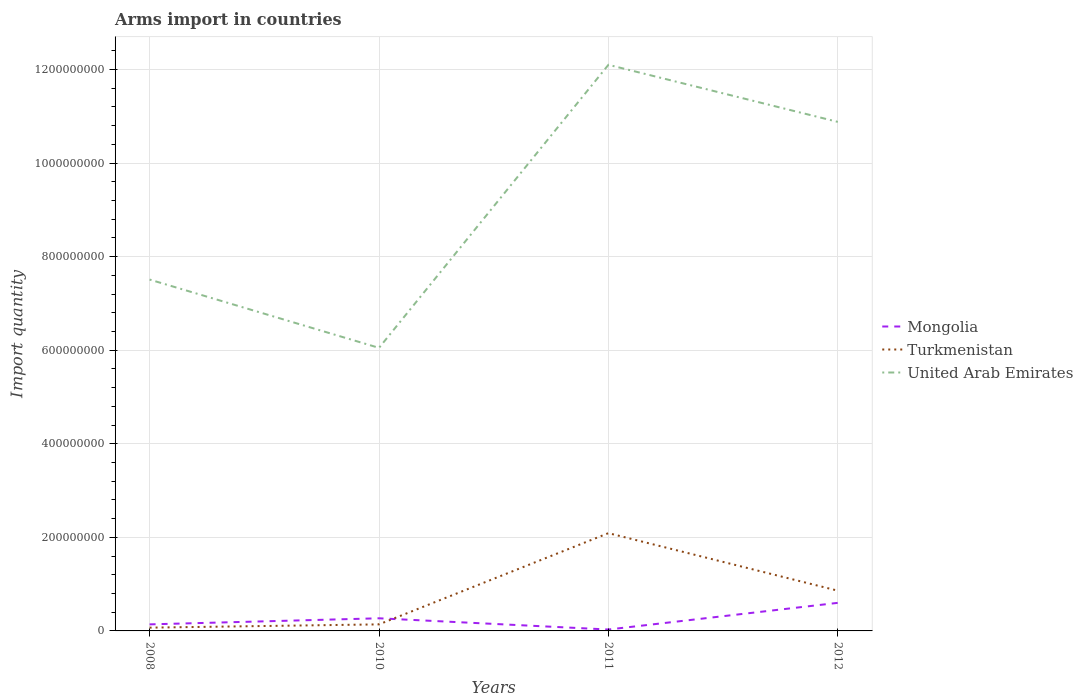How many different coloured lines are there?
Your answer should be compact. 3. Does the line corresponding to Turkmenistan intersect with the line corresponding to United Arab Emirates?
Your answer should be very brief. No. In which year was the total arms import in Turkmenistan maximum?
Make the answer very short. 2008. What is the total total arms import in Mongolia in the graph?
Provide a short and direct response. -3.30e+07. What is the difference between the highest and the second highest total arms import in United Arab Emirates?
Your response must be concise. 6.05e+08. What is the difference between the highest and the lowest total arms import in Mongolia?
Make the answer very short. 2. How many years are there in the graph?
Keep it short and to the point. 4. Are the values on the major ticks of Y-axis written in scientific E-notation?
Make the answer very short. No. Does the graph contain grids?
Your answer should be compact. Yes. How are the legend labels stacked?
Ensure brevity in your answer.  Vertical. What is the title of the graph?
Your answer should be very brief. Arms import in countries. What is the label or title of the X-axis?
Keep it short and to the point. Years. What is the label or title of the Y-axis?
Provide a short and direct response. Import quantity. What is the Import quantity of Mongolia in 2008?
Your answer should be very brief. 1.40e+07. What is the Import quantity in Turkmenistan in 2008?
Ensure brevity in your answer.  7.00e+06. What is the Import quantity of United Arab Emirates in 2008?
Your response must be concise. 7.51e+08. What is the Import quantity in Mongolia in 2010?
Make the answer very short. 2.70e+07. What is the Import quantity in Turkmenistan in 2010?
Make the answer very short. 1.40e+07. What is the Import quantity in United Arab Emirates in 2010?
Ensure brevity in your answer.  6.05e+08. What is the Import quantity of Turkmenistan in 2011?
Your response must be concise. 2.09e+08. What is the Import quantity of United Arab Emirates in 2011?
Your answer should be compact. 1.21e+09. What is the Import quantity in Mongolia in 2012?
Your answer should be compact. 6.00e+07. What is the Import quantity of Turkmenistan in 2012?
Offer a terse response. 8.60e+07. What is the Import quantity in United Arab Emirates in 2012?
Offer a very short reply. 1.09e+09. Across all years, what is the maximum Import quantity in Mongolia?
Ensure brevity in your answer.  6.00e+07. Across all years, what is the maximum Import quantity of Turkmenistan?
Provide a short and direct response. 2.09e+08. Across all years, what is the maximum Import quantity of United Arab Emirates?
Make the answer very short. 1.21e+09. Across all years, what is the minimum Import quantity of Turkmenistan?
Give a very brief answer. 7.00e+06. Across all years, what is the minimum Import quantity of United Arab Emirates?
Give a very brief answer. 6.05e+08. What is the total Import quantity in Mongolia in the graph?
Make the answer very short. 1.04e+08. What is the total Import quantity of Turkmenistan in the graph?
Offer a terse response. 3.16e+08. What is the total Import quantity of United Arab Emirates in the graph?
Provide a succinct answer. 3.65e+09. What is the difference between the Import quantity of Mongolia in 2008 and that in 2010?
Your answer should be very brief. -1.30e+07. What is the difference between the Import quantity of Turkmenistan in 2008 and that in 2010?
Your response must be concise. -7.00e+06. What is the difference between the Import quantity in United Arab Emirates in 2008 and that in 2010?
Keep it short and to the point. 1.46e+08. What is the difference between the Import quantity in Mongolia in 2008 and that in 2011?
Your answer should be compact. 1.10e+07. What is the difference between the Import quantity in Turkmenistan in 2008 and that in 2011?
Your response must be concise. -2.02e+08. What is the difference between the Import quantity in United Arab Emirates in 2008 and that in 2011?
Give a very brief answer. -4.59e+08. What is the difference between the Import quantity in Mongolia in 2008 and that in 2012?
Provide a short and direct response. -4.60e+07. What is the difference between the Import quantity of Turkmenistan in 2008 and that in 2012?
Provide a short and direct response. -7.90e+07. What is the difference between the Import quantity of United Arab Emirates in 2008 and that in 2012?
Provide a short and direct response. -3.37e+08. What is the difference between the Import quantity of Mongolia in 2010 and that in 2011?
Ensure brevity in your answer.  2.40e+07. What is the difference between the Import quantity of Turkmenistan in 2010 and that in 2011?
Provide a short and direct response. -1.95e+08. What is the difference between the Import quantity in United Arab Emirates in 2010 and that in 2011?
Offer a terse response. -6.05e+08. What is the difference between the Import quantity in Mongolia in 2010 and that in 2012?
Keep it short and to the point. -3.30e+07. What is the difference between the Import quantity of Turkmenistan in 2010 and that in 2012?
Keep it short and to the point. -7.20e+07. What is the difference between the Import quantity in United Arab Emirates in 2010 and that in 2012?
Keep it short and to the point. -4.83e+08. What is the difference between the Import quantity in Mongolia in 2011 and that in 2012?
Your answer should be very brief. -5.70e+07. What is the difference between the Import quantity in Turkmenistan in 2011 and that in 2012?
Provide a short and direct response. 1.23e+08. What is the difference between the Import quantity in United Arab Emirates in 2011 and that in 2012?
Offer a very short reply. 1.22e+08. What is the difference between the Import quantity of Mongolia in 2008 and the Import quantity of Turkmenistan in 2010?
Provide a succinct answer. 0. What is the difference between the Import quantity of Mongolia in 2008 and the Import quantity of United Arab Emirates in 2010?
Give a very brief answer. -5.91e+08. What is the difference between the Import quantity of Turkmenistan in 2008 and the Import quantity of United Arab Emirates in 2010?
Provide a short and direct response. -5.98e+08. What is the difference between the Import quantity of Mongolia in 2008 and the Import quantity of Turkmenistan in 2011?
Your answer should be compact. -1.95e+08. What is the difference between the Import quantity in Mongolia in 2008 and the Import quantity in United Arab Emirates in 2011?
Give a very brief answer. -1.20e+09. What is the difference between the Import quantity in Turkmenistan in 2008 and the Import quantity in United Arab Emirates in 2011?
Offer a very short reply. -1.20e+09. What is the difference between the Import quantity of Mongolia in 2008 and the Import quantity of Turkmenistan in 2012?
Ensure brevity in your answer.  -7.20e+07. What is the difference between the Import quantity of Mongolia in 2008 and the Import quantity of United Arab Emirates in 2012?
Offer a terse response. -1.07e+09. What is the difference between the Import quantity of Turkmenistan in 2008 and the Import quantity of United Arab Emirates in 2012?
Provide a short and direct response. -1.08e+09. What is the difference between the Import quantity of Mongolia in 2010 and the Import quantity of Turkmenistan in 2011?
Provide a succinct answer. -1.82e+08. What is the difference between the Import quantity in Mongolia in 2010 and the Import quantity in United Arab Emirates in 2011?
Make the answer very short. -1.18e+09. What is the difference between the Import quantity in Turkmenistan in 2010 and the Import quantity in United Arab Emirates in 2011?
Your response must be concise. -1.20e+09. What is the difference between the Import quantity of Mongolia in 2010 and the Import quantity of Turkmenistan in 2012?
Your answer should be compact. -5.90e+07. What is the difference between the Import quantity of Mongolia in 2010 and the Import quantity of United Arab Emirates in 2012?
Offer a terse response. -1.06e+09. What is the difference between the Import quantity of Turkmenistan in 2010 and the Import quantity of United Arab Emirates in 2012?
Offer a very short reply. -1.07e+09. What is the difference between the Import quantity in Mongolia in 2011 and the Import quantity in Turkmenistan in 2012?
Provide a short and direct response. -8.30e+07. What is the difference between the Import quantity of Mongolia in 2011 and the Import quantity of United Arab Emirates in 2012?
Provide a short and direct response. -1.08e+09. What is the difference between the Import quantity of Turkmenistan in 2011 and the Import quantity of United Arab Emirates in 2012?
Provide a short and direct response. -8.79e+08. What is the average Import quantity of Mongolia per year?
Your answer should be compact. 2.60e+07. What is the average Import quantity of Turkmenistan per year?
Your response must be concise. 7.90e+07. What is the average Import quantity in United Arab Emirates per year?
Ensure brevity in your answer.  9.14e+08. In the year 2008, what is the difference between the Import quantity of Mongolia and Import quantity of United Arab Emirates?
Keep it short and to the point. -7.37e+08. In the year 2008, what is the difference between the Import quantity in Turkmenistan and Import quantity in United Arab Emirates?
Ensure brevity in your answer.  -7.44e+08. In the year 2010, what is the difference between the Import quantity of Mongolia and Import quantity of Turkmenistan?
Give a very brief answer. 1.30e+07. In the year 2010, what is the difference between the Import quantity in Mongolia and Import quantity in United Arab Emirates?
Provide a succinct answer. -5.78e+08. In the year 2010, what is the difference between the Import quantity of Turkmenistan and Import quantity of United Arab Emirates?
Your response must be concise. -5.91e+08. In the year 2011, what is the difference between the Import quantity of Mongolia and Import quantity of Turkmenistan?
Provide a short and direct response. -2.06e+08. In the year 2011, what is the difference between the Import quantity in Mongolia and Import quantity in United Arab Emirates?
Your answer should be compact. -1.21e+09. In the year 2011, what is the difference between the Import quantity in Turkmenistan and Import quantity in United Arab Emirates?
Offer a terse response. -1.00e+09. In the year 2012, what is the difference between the Import quantity in Mongolia and Import quantity in Turkmenistan?
Ensure brevity in your answer.  -2.60e+07. In the year 2012, what is the difference between the Import quantity of Mongolia and Import quantity of United Arab Emirates?
Offer a terse response. -1.03e+09. In the year 2012, what is the difference between the Import quantity of Turkmenistan and Import quantity of United Arab Emirates?
Provide a short and direct response. -1.00e+09. What is the ratio of the Import quantity in Mongolia in 2008 to that in 2010?
Your answer should be very brief. 0.52. What is the ratio of the Import quantity in United Arab Emirates in 2008 to that in 2010?
Make the answer very short. 1.24. What is the ratio of the Import quantity of Mongolia in 2008 to that in 2011?
Offer a terse response. 4.67. What is the ratio of the Import quantity of Turkmenistan in 2008 to that in 2011?
Provide a succinct answer. 0.03. What is the ratio of the Import quantity of United Arab Emirates in 2008 to that in 2011?
Make the answer very short. 0.62. What is the ratio of the Import quantity of Mongolia in 2008 to that in 2012?
Offer a very short reply. 0.23. What is the ratio of the Import quantity in Turkmenistan in 2008 to that in 2012?
Offer a terse response. 0.08. What is the ratio of the Import quantity in United Arab Emirates in 2008 to that in 2012?
Your answer should be compact. 0.69. What is the ratio of the Import quantity of Turkmenistan in 2010 to that in 2011?
Offer a terse response. 0.07. What is the ratio of the Import quantity in Mongolia in 2010 to that in 2012?
Your response must be concise. 0.45. What is the ratio of the Import quantity of Turkmenistan in 2010 to that in 2012?
Provide a succinct answer. 0.16. What is the ratio of the Import quantity in United Arab Emirates in 2010 to that in 2012?
Keep it short and to the point. 0.56. What is the ratio of the Import quantity in Mongolia in 2011 to that in 2012?
Ensure brevity in your answer.  0.05. What is the ratio of the Import quantity in Turkmenistan in 2011 to that in 2012?
Offer a terse response. 2.43. What is the ratio of the Import quantity in United Arab Emirates in 2011 to that in 2012?
Your answer should be compact. 1.11. What is the difference between the highest and the second highest Import quantity of Mongolia?
Provide a short and direct response. 3.30e+07. What is the difference between the highest and the second highest Import quantity of Turkmenistan?
Ensure brevity in your answer.  1.23e+08. What is the difference between the highest and the second highest Import quantity of United Arab Emirates?
Ensure brevity in your answer.  1.22e+08. What is the difference between the highest and the lowest Import quantity of Mongolia?
Make the answer very short. 5.70e+07. What is the difference between the highest and the lowest Import quantity in Turkmenistan?
Your answer should be very brief. 2.02e+08. What is the difference between the highest and the lowest Import quantity of United Arab Emirates?
Make the answer very short. 6.05e+08. 